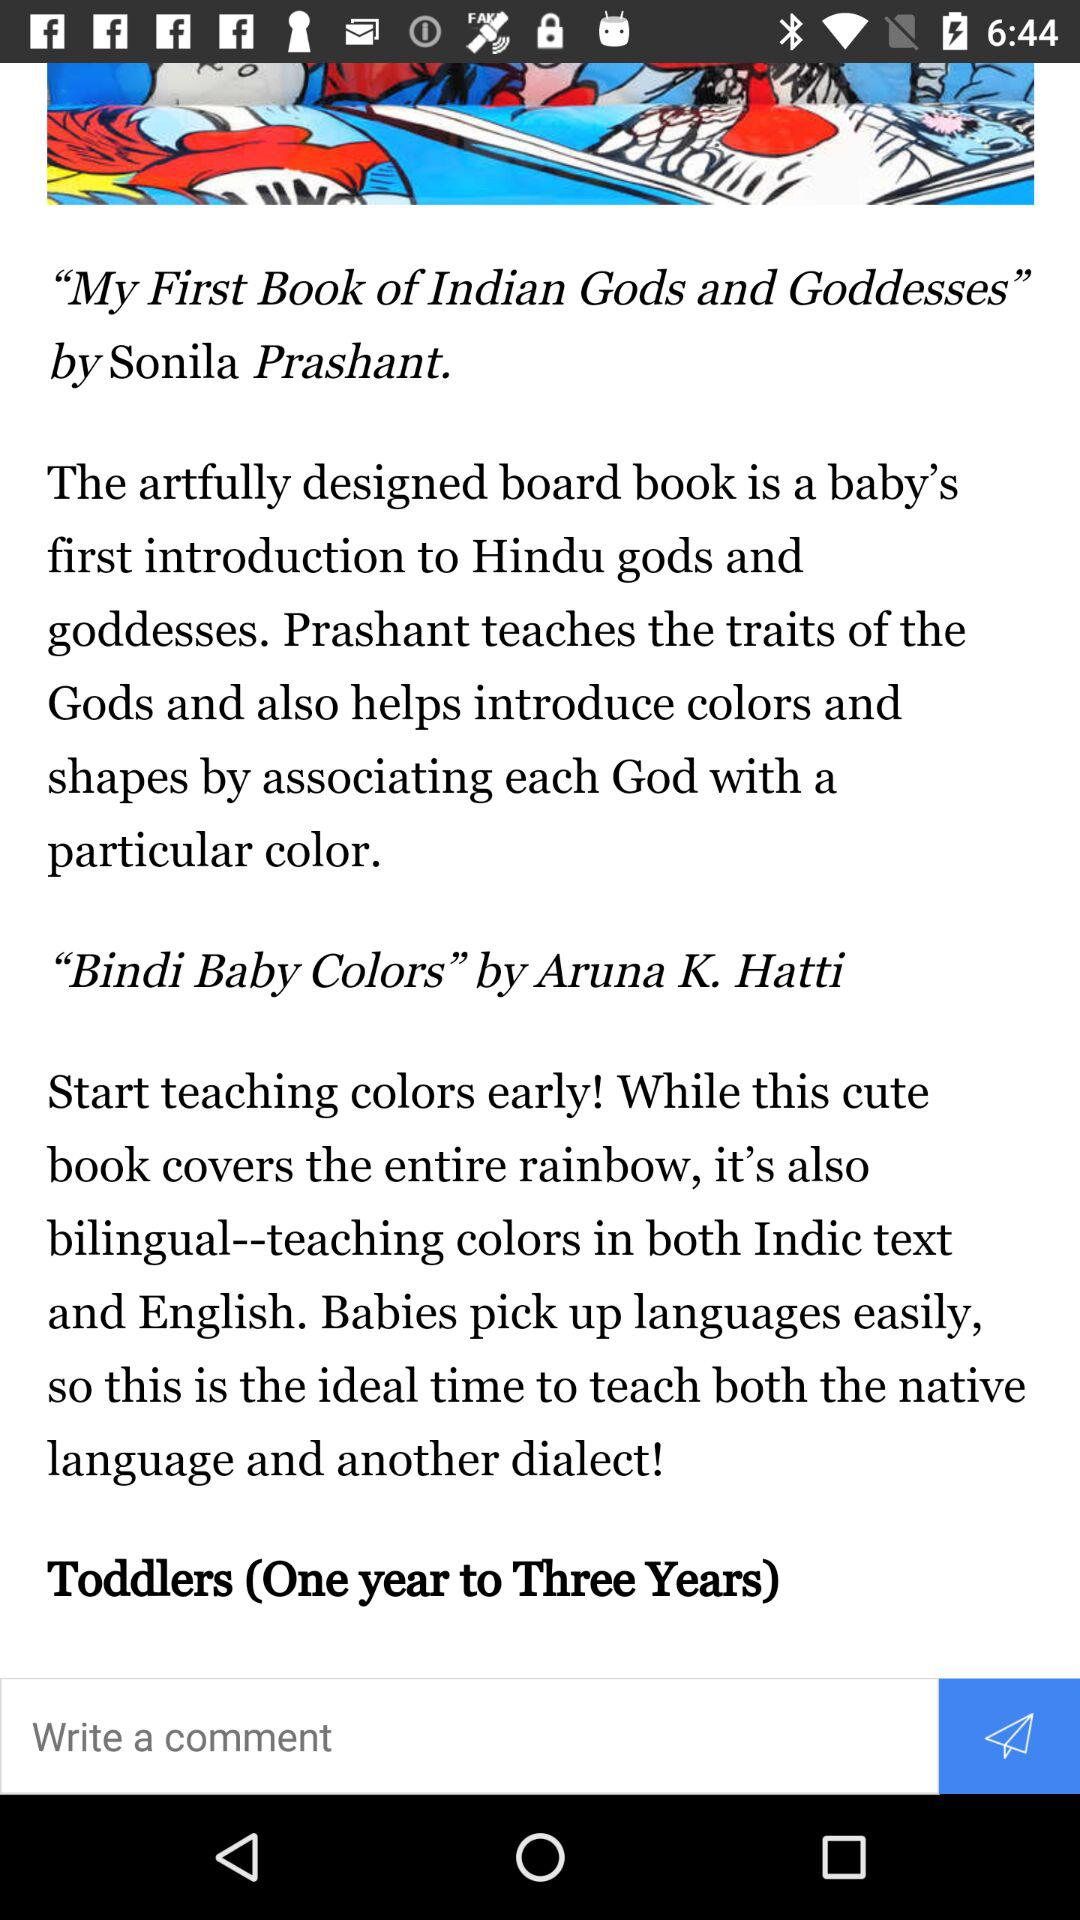Who is the writer of ""My First Book of Indian Gods and Goddesses""? The writer of "My First Book of Indian Gods and Goddesses" is Sonila Prashant. 